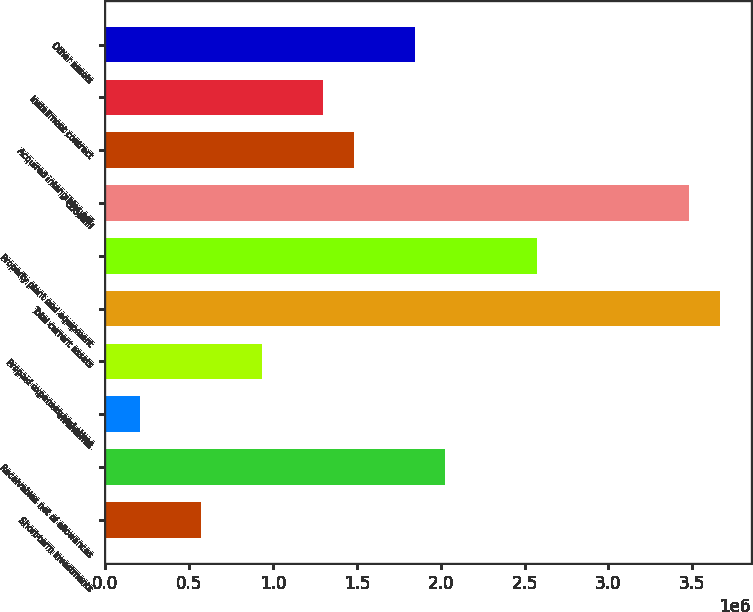Convert chart. <chart><loc_0><loc_0><loc_500><loc_500><bar_chart><fcel>Short-term investments<fcel>Receivables net of allowances<fcel>Inventories<fcel>Prepaid expenses and other<fcel>Total current assets<fcel>Property plant and equipment<fcel>Goodwill<fcel>Acquired intangibles net<fcel>Installment contract<fcel>Other assets<nl><fcel>570122<fcel>2.02679e+06<fcel>205956<fcel>934288<fcel>3.66554e+06<fcel>2.57304e+06<fcel>3.48345e+06<fcel>1.48054e+06<fcel>1.29845e+06<fcel>1.8447e+06<nl></chart> 